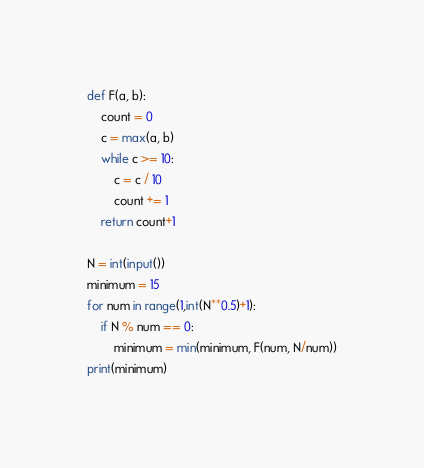<code> <loc_0><loc_0><loc_500><loc_500><_Python_>def F(a, b):
    count = 0
    c = max(a, b)
    while c >= 10:
        c = c / 10
        count += 1
    return count+1
 
N = int(input())
minimum = 15
for num in range(1,int(N**0.5)+1):
    if N % num == 0:
        minimum = min(minimum, F(num, N/num))
print(minimum)</code> 